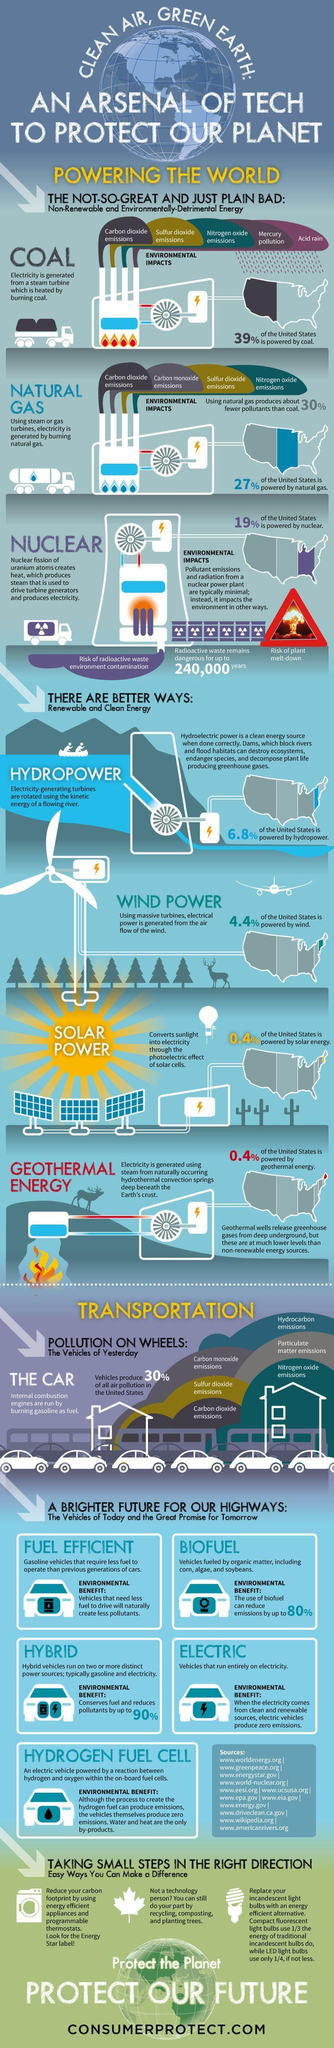Which region of the United states is still powered by coal, the west, the south, the midwest or the north east?
Answer the question with a short phrase. the west Which are the non renewable sources of energy? Coal, Natural gas, Nuclear What percentage of United States uses Solar power and Geo thermal energy to produce electricity? 0.4% What is the total percentage of renewable sources of energy used by US? 12% What is the total percentage of non-renewable sources of energy used by US? 85% 